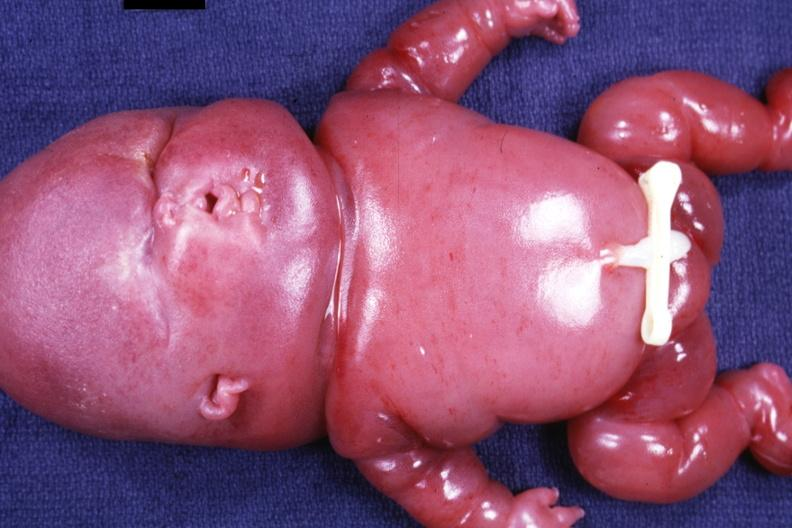what does this image show?
Answer the question using a single word or phrase. Newborn infant 24 week gestation weight gm typical grotesque appearance 